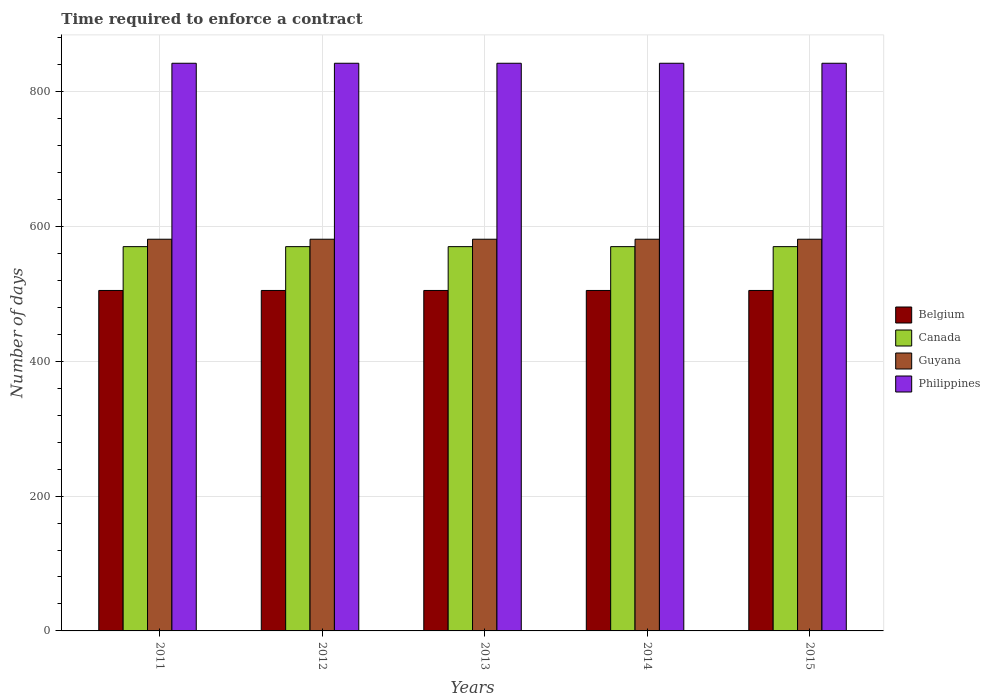How many bars are there on the 1st tick from the left?
Ensure brevity in your answer.  4. How many bars are there on the 5th tick from the right?
Your answer should be very brief. 4. What is the label of the 5th group of bars from the left?
Offer a very short reply. 2015. In how many cases, is the number of bars for a given year not equal to the number of legend labels?
Your answer should be very brief. 0. What is the number of days required to enforce a contract in Guyana in 2015?
Provide a succinct answer. 581. Across all years, what is the maximum number of days required to enforce a contract in Belgium?
Make the answer very short. 505. Across all years, what is the minimum number of days required to enforce a contract in Belgium?
Your response must be concise. 505. What is the total number of days required to enforce a contract in Belgium in the graph?
Offer a very short reply. 2525. What is the difference between the number of days required to enforce a contract in Belgium in 2014 and the number of days required to enforce a contract in Guyana in 2013?
Offer a very short reply. -76. What is the average number of days required to enforce a contract in Canada per year?
Give a very brief answer. 570. In the year 2015, what is the difference between the number of days required to enforce a contract in Philippines and number of days required to enforce a contract in Guyana?
Your answer should be compact. 261. What is the ratio of the number of days required to enforce a contract in Canada in 2011 to that in 2015?
Offer a very short reply. 1. Is the number of days required to enforce a contract in Guyana in 2011 less than that in 2013?
Make the answer very short. No. Is the difference between the number of days required to enforce a contract in Philippines in 2012 and 2013 greater than the difference between the number of days required to enforce a contract in Guyana in 2012 and 2013?
Provide a succinct answer. No. What is the difference between the highest and the lowest number of days required to enforce a contract in Canada?
Provide a short and direct response. 0. In how many years, is the number of days required to enforce a contract in Guyana greater than the average number of days required to enforce a contract in Guyana taken over all years?
Keep it short and to the point. 0. Is it the case that in every year, the sum of the number of days required to enforce a contract in Belgium and number of days required to enforce a contract in Philippines is greater than the sum of number of days required to enforce a contract in Canada and number of days required to enforce a contract in Guyana?
Provide a short and direct response. Yes. Are the values on the major ticks of Y-axis written in scientific E-notation?
Offer a very short reply. No. Does the graph contain grids?
Provide a short and direct response. Yes. Where does the legend appear in the graph?
Provide a succinct answer. Center right. How many legend labels are there?
Keep it short and to the point. 4. What is the title of the graph?
Your answer should be very brief. Time required to enforce a contract. Does "High income: nonOECD" appear as one of the legend labels in the graph?
Give a very brief answer. No. What is the label or title of the Y-axis?
Give a very brief answer. Number of days. What is the Number of days of Belgium in 2011?
Give a very brief answer. 505. What is the Number of days in Canada in 2011?
Offer a very short reply. 570. What is the Number of days of Guyana in 2011?
Provide a succinct answer. 581. What is the Number of days of Philippines in 2011?
Provide a succinct answer. 842. What is the Number of days of Belgium in 2012?
Make the answer very short. 505. What is the Number of days of Canada in 2012?
Make the answer very short. 570. What is the Number of days in Guyana in 2012?
Your answer should be compact. 581. What is the Number of days of Philippines in 2012?
Offer a terse response. 842. What is the Number of days of Belgium in 2013?
Offer a terse response. 505. What is the Number of days of Canada in 2013?
Offer a terse response. 570. What is the Number of days of Guyana in 2013?
Offer a terse response. 581. What is the Number of days in Philippines in 2013?
Provide a succinct answer. 842. What is the Number of days in Belgium in 2014?
Give a very brief answer. 505. What is the Number of days of Canada in 2014?
Provide a short and direct response. 570. What is the Number of days in Guyana in 2014?
Make the answer very short. 581. What is the Number of days of Philippines in 2014?
Offer a terse response. 842. What is the Number of days in Belgium in 2015?
Ensure brevity in your answer.  505. What is the Number of days in Canada in 2015?
Offer a very short reply. 570. What is the Number of days in Guyana in 2015?
Provide a succinct answer. 581. What is the Number of days of Philippines in 2015?
Give a very brief answer. 842. Across all years, what is the maximum Number of days of Belgium?
Ensure brevity in your answer.  505. Across all years, what is the maximum Number of days in Canada?
Keep it short and to the point. 570. Across all years, what is the maximum Number of days in Guyana?
Your response must be concise. 581. Across all years, what is the maximum Number of days in Philippines?
Offer a terse response. 842. Across all years, what is the minimum Number of days of Belgium?
Make the answer very short. 505. Across all years, what is the minimum Number of days of Canada?
Provide a short and direct response. 570. Across all years, what is the minimum Number of days of Guyana?
Provide a succinct answer. 581. Across all years, what is the minimum Number of days of Philippines?
Your answer should be compact. 842. What is the total Number of days of Belgium in the graph?
Your answer should be compact. 2525. What is the total Number of days of Canada in the graph?
Give a very brief answer. 2850. What is the total Number of days of Guyana in the graph?
Ensure brevity in your answer.  2905. What is the total Number of days of Philippines in the graph?
Offer a very short reply. 4210. What is the difference between the Number of days of Guyana in 2011 and that in 2012?
Ensure brevity in your answer.  0. What is the difference between the Number of days in Philippines in 2011 and that in 2012?
Provide a short and direct response. 0. What is the difference between the Number of days in Belgium in 2011 and that in 2013?
Offer a very short reply. 0. What is the difference between the Number of days in Philippines in 2011 and that in 2013?
Provide a succinct answer. 0. What is the difference between the Number of days in Canada in 2011 and that in 2014?
Provide a short and direct response. 0. What is the difference between the Number of days in Philippines in 2011 and that in 2014?
Your answer should be very brief. 0. What is the difference between the Number of days in Guyana in 2011 and that in 2015?
Give a very brief answer. 0. What is the difference between the Number of days in Canada in 2012 and that in 2013?
Your response must be concise. 0. What is the difference between the Number of days of Guyana in 2012 and that in 2013?
Ensure brevity in your answer.  0. What is the difference between the Number of days in Belgium in 2012 and that in 2014?
Make the answer very short. 0. What is the difference between the Number of days of Canada in 2012 and that in 2015?
Your response must be concise. 0. What is the difference between the Number of days of Philippines in 2012 and that in 2015?
Offer a very short reply. 0. What is the difference between the Number of days in Belgium in 2013 and that in 2014?
Give a very brief answer. 0. What is the difference between the Number of days in Canada in 2013 and that in 2015?
Your answer should be very brief. 0. What is the difference between the Number of days in Guyana in 2014 and that in 2015?
Provide a succinct answer. 0. What is the difference between the Number of days in Philippines in 2014 and that in 2015?
Your response must be concise. 0. What is the difference between the Number of days of Belgium in 2011 and the Number of days of Canada in 2012?
Ensure brevity in your answer.  -65. What is the difference between the Number of days in Belgium in 2011 and the Number of days in Guyana in 2012?
Keep it short and to the point. -76. What is the difference between the Number of days of Belgium in 2011 and the Number of days of Philippines in 2012?
Ensure brevity in your answer.  -337. What is the difference between the Number of days in Canada in 2011 and the Number of days in Guyana in 2012?
Ensure brevity in your answer.  -11. What is the difference between the Number of days in Canada in 2011 and the Number of days in Philippines in 2012?
Your answer should be very brief. -272. What is the difference between the Number of days of Guyana in 2011 and the Number of days of Philippines in 2012?
Provide a short and direct response. -261. What is the difference between the Number of days of Belgium in 2011 and the Number of days of Canada in 2013?
Provide a succinct answer. -65. What is the difference between the Number of days in Belgium in 2011 and the Number of days in Guyana in 2013?
Make the answer very short. -76. What is the difference between the Number of days in Belgium in 2011 and the Number of days in Philippines in 2013?
Offer a terse response. -337. What is the difference between the Number of days in Canada in 2011 and the Number of days in Guyana in 2013?
Your response must be concise. -11. What is the difference between the Number of days of Canada in 2011 and the Number of days of Philippines in 2013?
Your response must be concise. -272. What is the difference between the Number of days in Guyana in 2011 and the Number of days in Philippines in 2013?
Make the answer very short. -261. What is the difference between the Number of days in Belgium in 2011 and the Number of days in Canada in 2014?
Make the answer very short. -65. What is the difference between the Number of days of Belgium in 2011 and the Number of days of Guyana in 2014?
Provide a succinct answer. -76. What is the difference between the Number of days in Belgium in 2011 and the Number of days in Philippines in 2014?
Make the answer very short. -337. What is the difference between the Number of days in Canada in 2011 and the Number of days in Philippines in 2014?
Offer a very short reply. -272. What is the difference between the Number of days in Guyana in 2011 and the Number of days in Philippines in 2014?
Offer a terse response. -261. What is the difference between the Number of days in Belgium in 2011 and the Number of days in Canada in 2015?
Offer a very short reply. -65. What is the difference between the Number of days of Belgium in 2011 and the Number of days of Guyana in 2015?
Your answer should be compact. -76. What is the difference between the Number of days of Belgium in 2011 and the Number of days of Philippines in 2015?
Make the answer very short. -337. What is the difference between the Number of days in Canada in 2011 and the Number of days in Guyana in 2015?
Make the answer very short. -11. What is the difference between the Number of days of Canada in 2011 and the Number of days of Philippines in 2015?
Provide a succinct answer. -272. What is the difference between the Number of days in Guyana in 2011 and the Number of days in Philippines in 2015?
Your answer should be compact. -261. What is the difference between the Number of days of Belgium in 2012 and the Number of days of Canada in 2013?
Offer a very short reply. -65. What is the difference between the Number of days of Belgium in 2012 and the Number of days of Guyana in 2013?
Keep it short and to the point. -76. What is the difference between the Number of days of Belgium in 2012 and the Number of days of Philippines in 2013?
Provide a succinct answer. -337. What is the difference between the Number of days in Canada in 2012 and the Number of days in Philippines in 2013?
Ensure brevity in your answer.  -272. What is the difference between the Number of days in Guyana in 2012 and the Number of days in Philippines in 2013?
Provide a succinct answer. -261. What is the difference between the Number of days in Belgium in 2012 and the Number of days in Canada in 2014?
Offer a very short reply. -65. What is the difference between the Number of days of Belgium in 2012 and the Number of days of Guyana in 2014?
Provide a succinct answer. -76. What is the difference between the Number of days of Belgium in 2012 and the Number of days of Philippines in 2014?
Provide a short and direct response. -337. What is the difference between the Number of days in Canada in 2012 and the Number of days in Philippines in 2014?
Offer a very short reply. -272. What is the difference between the Number of days in Guyana in 2012 and the Number of days in Philippines in 2014?
Give a very brief answer. -261. What is the difference between the Number of days of Belgium in 2012 and the Number of days of Canada in 2015?
Ensure brevity in your answer.  -65. What is the difference between the Number of days in Belgium in 2012 and the Number of days in Guyana in 2015?
Your answer should be compact. -76. What is the difference between the Number of days of Belgium in 2012 and the Number of days of Philippines in 2015?
Make the answer very short. -337. What is the difference between the Number of days in Canada in 2012 and the Number of days in Guyana in 2015?
Your answer should be very brief. -11. What is the difference between the Number of days of Canada in 2012 and the Number of days of Philippines in 2015?
Provide a succinct answer. -272. What is the difference between the Number of days of Guyana in 2012 and the Number of days of Philippines in 2015?
Ensure brevity in your answer.  -261. What is the difference between the Number of days of Belgium in 2013 and the Number of days of Canada in 2014?
Your answer should be very brief. -65. What is the difference between the Number of days in Belgium in 2013 and the Number of days in Guyana in 2014?
Your answer should be very brief. -76. What is the difference between the Number of days of Belgium in 2013 and the Number of days of Philippines in 2014?
Provide a succinct answer. -337. What is the difference between the Number of days of Canada in 2013 and the Number of days of Guyana in 2014?
Your answer should be compact. -11. What is the difference between the Number of days of Canada in 2013 and the Number of days of Philippines in 2014?
Keep it short and to the point. -272. What is the difference between the Number of days in Guyana in 2013 and the Number of days in Philippines in 2014?
Your answer should be very brief. -261. What is the difference between the Number of days of Belgium in 2013 and the Number of days of Canada in 2015?
Your response must be concise. -65. What is the difference between the Number of days of Belgium in 2013 and the Number of days of Guyana in 2015?
Offer a terse response. -76. What is the difference between the Number of days of Belgium in 2013 and the Number of days of Philippines in 2015?
Offer a very short reply. -337. What is the difference between the Number of days in Canada in 2013 and the Number of days in Guyana in 2015?
Offer a very short reply. -11. What is the difference between the Number of days of Canada in 2013 and the Number of days of Philippines in 2015?
Your answer should be very brief. -272. What is the difference between the Number of days in Guyana in 2013 and the Number of days in Philippines in 2015?
Provide a succinct answer. -261. What is the difference between the Number of days of Belgium in 2014 and the Number of days of Canada in 2015?
Provide a short and direct response. -65. What is the difference between the Number of days of Belgium in 2014 and the Number of days of Guyana in 2015?
Provide a succinct answer. -76. What is the difference between the Number of days of Belgium in 2014 and the Number of days of Philippines in 2015?
Provide a short and direct response. -337. What is the difference between the Number of days of Canada in 2014 and the Number of days of Philippines in 2015?
Your response must be concise. -272. What is the difference between the Number of days in Guyana in 2014 and the Number of days in Philippines in 2015?
Make the answer very short. -261. What is the average Number of days in Belgium per year?
Ensure brevity in your answer.  505. What is the average Number of days of Canada per year?
Your response must be concise. 570. What is the average Number of days of Guyana per year?
Give a very brief answer. 581. What is the average Number of days in Philippines per year?
Provide a succinct answer. 842. In the year 2011, what is the difference between the Number of days in Belgium and Number of days in Canada?
Your answer should be compact. -65. In the year 2011, what is the difference between the Number of days of Belgium and Number of days of Guyana?
Your answer should be compact. -76. In the year 2011, what is the difference between the Number of days of Belgium and Number of days of Philippines?
Ensure brevity in your answer.  -337. In the year 2011, what is the difference between the Number of days of Canada and Number of days of Philippines?
Offer a very short reply. -272. In the year 2011, what is the difference between the Number of days in Guyana and Number of days in Philippines?
Your response must be concise. -261. In the year 2012, what is the difference between the Number of days in Belgium and Number of days in Canada?
Provide a short and direct response. -65. In the year 2012, what is the difference between the Number of days in Belgium and Number of days in Guyana?
Offer a very short reply. -76. In the year 2012, what is the difference between the Number of days of Belgium and Number of days of Philippines?
Keep it short and to the point. -337. In the year 2012, what is the difference between the Number of days of Canada and Number of days of Guyana?
Make the answer very short. -11. In the year 2012, what is the difference between the Number of days of Canada and Number of days of Philippines?
Your answer should be compact. -272. In the year 2012, what is the difference between the Number of days in Guyana and Number of days in Philippines?
Offer a very short reply. -261. In the year 2013, what is the difference between the Number of days of Belgium and Number of days of Canada?
Make the answer very short. -65. In the year 2013, what is the difference between the Number of days in Belgium and Number of days in Guyana?
Your answer should be very brief. -76. In the year 2013, what is the difference between the Number of days of Belgium and Number of days of Philippines?
Make the answer very short. -337. In the year 2013, what is the difference between the Number of days in Canada and Number of days in Philippines?
Your answer should be compact. -272. In the year 2013, what is the difference between the Number of days in Guyana and Number of days in Philippines?
Provide a short and direct response. -261. In the year 2014, what is the difference between the Number of days in Belgium and Number of days in Canada?
Ensure brevity in your answer.  -65. In the year 2014, what is the difference between the Number of days in Belgium and Number of days in Guyana?
Your response must be concise. -76. In the year 2014, what is the difference between the Number of days of Belgium and Number of days of Philippines?
Give a very brief answer. -337. In the year 2014, what is the difference between the Number of days in Canada and Number of days in Guyana?
Your answer should be very brief. -11. In the year 2014, what is the difference between the Number of days in Canada and Number of days in Philippines?
Offer a very short reply. -272. In the year 2014, what is the difference between the Number of days in Guyana and Number of days in Philippines?
Your answer should be very brief. -261. In the year 2015, what is the difference between the Number of days of Belgium and Number of days of Canada?
Your answer should be very brief. -65. In the year 2015, what is the difference between the Number of days in Belgium and Number of days in Guyana?
Give a very brief answer. -76. In the year 2015, what is the difference between the Number of days in Belgium and Number of days in Philippines?
Provide a succinct answer. -337. In the year 2015, what is the difference between the Number of days in Canada and Number of days in Philippines?
Your response must be concise. -272. In the year 2015, what is the difference between the Number of days in Guyana and Number of days in Philippines?
Offer a terse response. -261. What is the ratio of the Number of days in Belgium in 2011 to that in 2013?
Make the answer very short. 1. What is the ratio of the Number of days of Canada in 2011 to that in 2013?
Give a very brief answer. 1. What is the ratio of the Number of days of Guyana in 2011 to that in 2013?
Your answer should be compact. 1. What is the ratio of the Number of days in Belgium in 2011 to that in 2014?
Your answer should be very brief. 1. What is the ratio of the Number of days in Canada in 2011 to that in 2014?
Ensure brevity in your answer.  1. What is the ratio of the Number of days of Belgium in 2011 to that in 2015?
Your answer should be very brief. 1. What is the ratio of the Number of days of Canada in 2011 to that in 2015?
Your answer should be very brief. 1. What is the ratio of the Number of days in Belgium in 2012 to that in 2013?
Provide a short and direct response. 1. What is the ratio of the Number of days in Canada in 2012 to that in 2013?
Ensure brevity in your answer.  1. What is the ratio of the Number of days in Guyana in 2012 to that in 2013?
Offer a very short reply. 1. What is the ratio of the Number of days of Philippines in 2012 to that in 2013?
Provide a short and direct response. 1. What is the ratio of the Number of days of Guyana in 2012 to that in 2014?
Ensure brevity in your answer.  1. What is the ratio of the Number of days in Philippines in 2012 to that in 2014?
Give a very brief answer. 1. What is the ratio of the Number of days in Canada in 2012 to that in 2015?
Your response must be concise. 1. What is the ratio of the Number of days in Guyana in 2012 to that in 2015?
Ensure brevity in your answer.  1. What is the ratio of the Number of days of Philippines in 2012 to that in 2015?
Offer a terse response. 1. What is the ratio of the Number of days of Belgium in 2013 to that in 2014?
Provide a short and direct response. 1. What is the ratio of the Number of days in Canada in 2013 to that in 2014?
Give a very brief answer. 1. What is the ratio of the Number of days of Belgium in 2013 to that in 2015?
Give a very brief answer. 1. What is the ratio of the Number of days of Guyana in 2013 to that in 2015?
Give a very brief answer. 1. What is the ratio of the Number of days in Canada in 2014 to that in 2015?
Offer a terse response. 1. What is the difference between the highest and the second highest Number of days of Belgium?
Your response must be concise. 0. What is the difference between the highest and the second highest Number of days in Guyana?
Make the answer very short. 0. What is the difference between the highest and the lowest Number of days in Belgium?
Offer a terse response. 0. What is the difference between the highest and the lowest Number of days of Canada?
Ensure brevity in your answer.  0. 